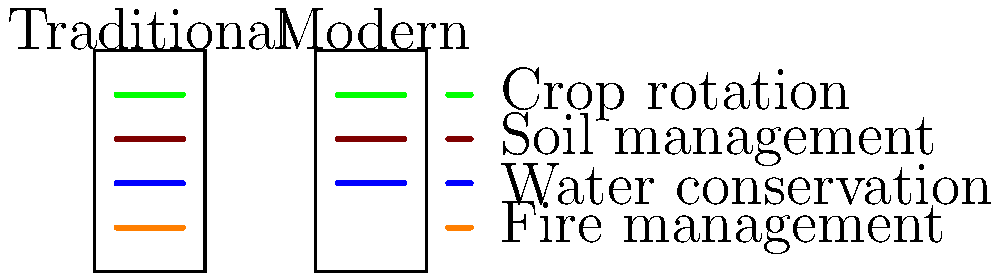Based on the side-by-side diagrams comparing traditional indigenous land management practices with modern conservation techniques, which practice is present in the traditional approach but often overlooked in modern conservation? Explain the potential benefits of incorporating this practice into contemporary land management strategies. To answer this question, we need to analyze the diagrams step-by-step:

1. The diagram shows two columns: "Traditional" and "Modern" land management practices.

2. Both columns share three common practices:
   a. Green line: Crop rotation
   b. Brown line: Soil management
   c. Blue line: Water conservation

3. The traditional column includes an additional orange line, which is not present in the modern column.

4. The legend indicates that the orange line represents fire management.

5. Fire management is a practice often used by indigenous communities for various purposes:
   a. Clearing land for agriculture
   b. Promoting biodiversity
   c. Reducing fuel load to prevent larger, uncontrolled wildfires
   d. Stimulating new growth and improving habitat for certain species

6. Modern conservation techniques often overlook fire management due to concerns about safety and potential ecological damage.

7. Incorporating traditional fire management into contemporary strategies could offer several benefits:
   a. Reduced risk of catastrophic wildfires
   b. Improved ecosystem health and biodiversity
   c. Preservation of cultural practices and knowledge
   d. Enhanced resilience to climate change impacts

8. The integration of fire management would represent a more holistic approach to land management, combining traditional ecological knowledge with modern scientific understanding.
Answer: Fire management; benefits include reduced wildfire risk, improved ecosystem health, cultural preservation, and enhanced climate resilience. 